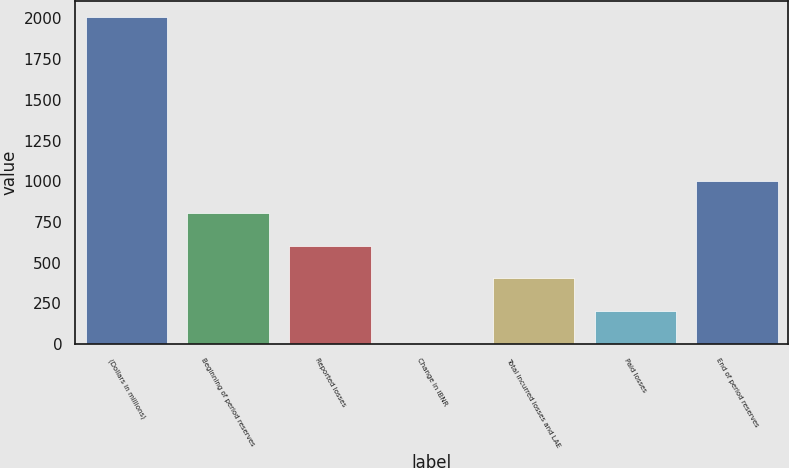Convert chart. <chart><loc_0><loc_0><loc_500><loc_500><bar_chart><fcel>(Dollars in millions)<fcel>Beginning of period reserves<fcel>Reported losses<fcel>Change in IBNR<fcel>Total incurred losses and LAE<fcel>Paid losses<fcel>End of period reserves<nl><fcel>2006<fcel>804.02<fcel>603.69<fcel>2.7<fcel>403.36<fcel>203.03<fcel>1004.35<nl></chart> 